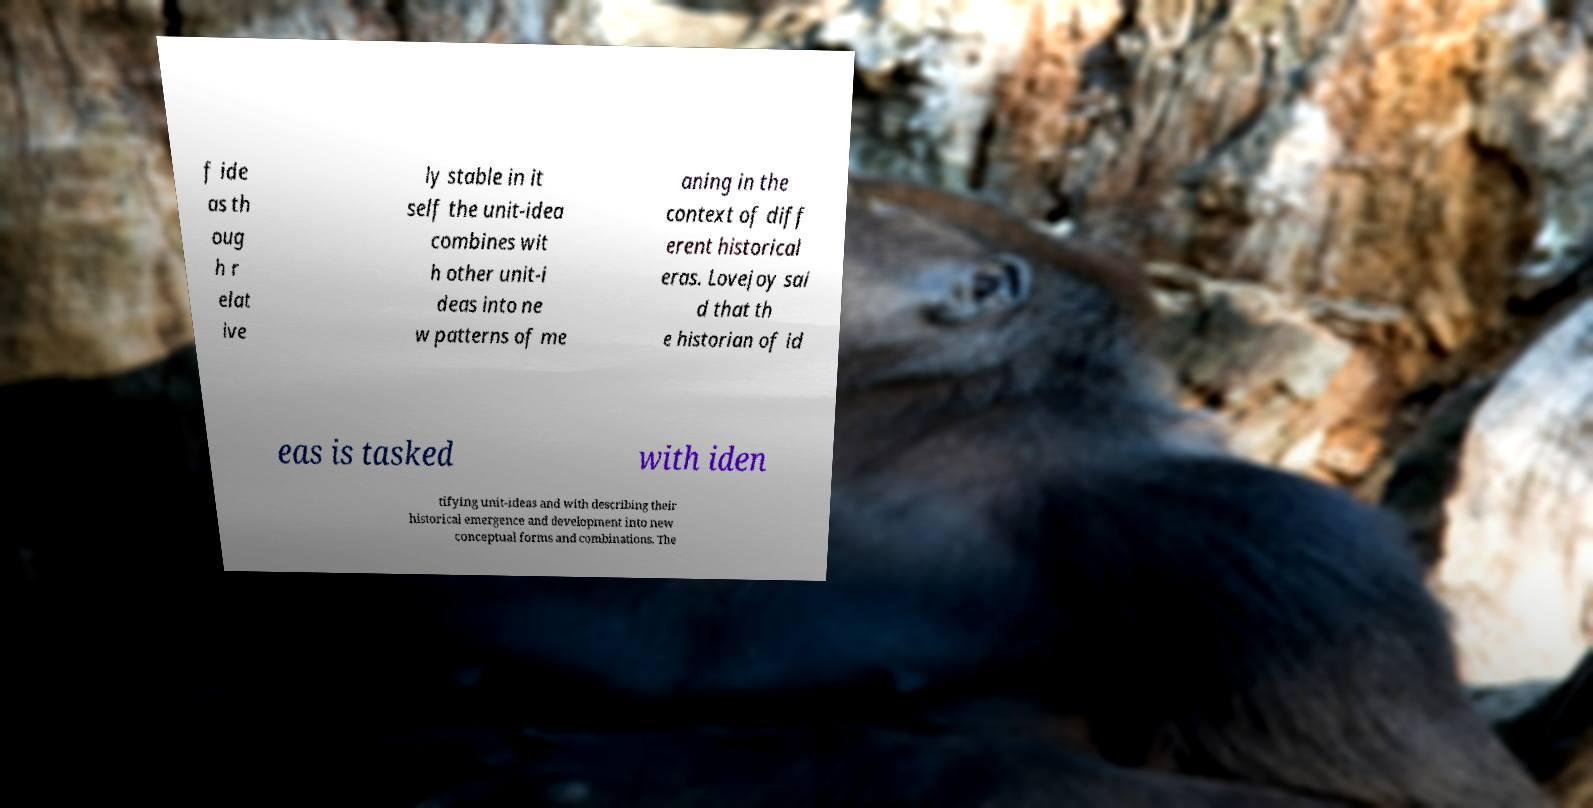I need the written content from this picture converted into text. Can you do that? f ide as th oug h r elat ive ly stable in it self the unit-idea combines wit h other unit-i deas into ne w patterns of me aning in the context of diff erent historical eras. Lovejoy sai d that th e historian of id eas is tasked with iden tifying unit-ideas and with describing their historical emergence and development into new conceptual forms and combinations. The 